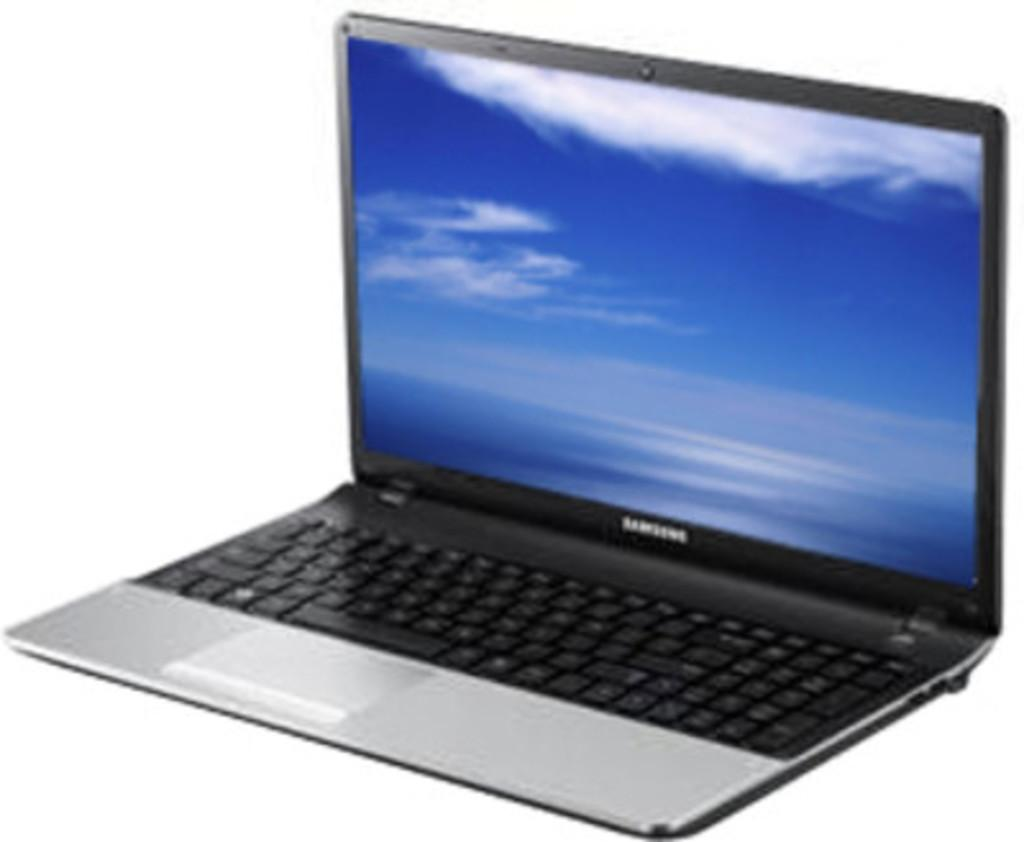<image>
Provide a brief description of the given image. A Samsung laptop sits with the screen saver on. 